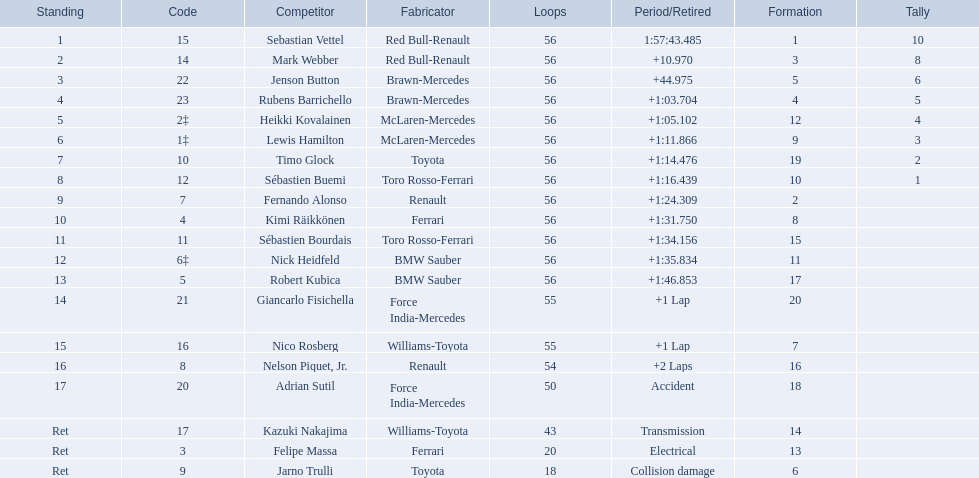Who are all of the drivers? Sebastian Vettel, Mark Webber, Jenson Button, Rubens Barrichello, Heikki Kovalainen, Lewis Hamilton, Timo Glock, Sébastien Buemi, Fernando Alonso, Kimi Räikkönen, Sébastien Bourdais, Nick Heidfeld, Robert Kubica, Giancarlo Fisichella, Nico Rosberg, Nelson Piquet, Jr., Adrian Sutil, Kazuki Nakajima, Felipe Massa, Jarno Trulli. Who were their constructors? Red Bull-Renault, Red Bull-Renault, Brawn-Mercedes, Brawn-Mercedes, McLaren-Mercedes, McLaren-Mercedes, Toyota, Toro Rosso-Ferrari, Renault, Ferrari, Toro Rosso-Ferrari, BMW Sauber, BMW Sauber, Force India-Mercedes, Williams-Toyota, Renault, Force India-Mercedes, Williams-Toyota, Ferrari, Toyota. Who was the first listed driver to not drive a ferrari?? Sebastian Vettel. 